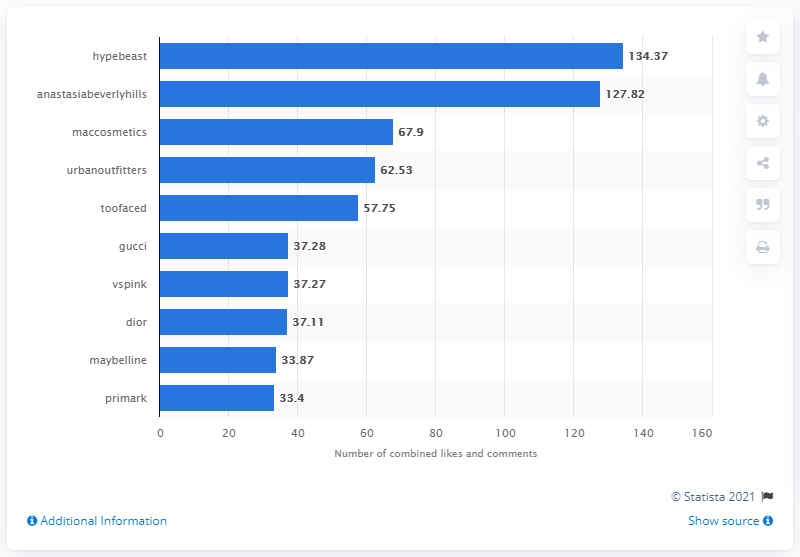Highlight a few significant elements in this photo. Hypebeast had 134.37 Instagram interactions. Anastasia Beverly Hills had 127.82 Instagram interactions. 